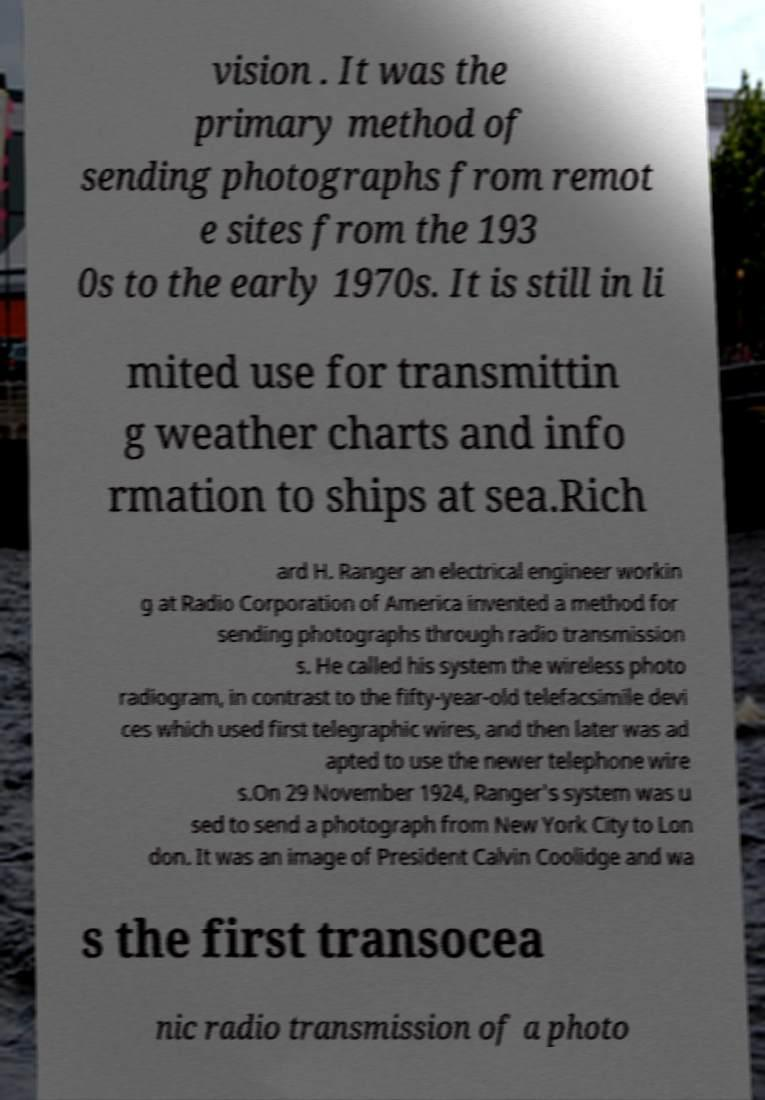For documentation purposes, I need the text within this image transcribed. Could you provide that? vision . It was the primary method of sending photographs from remot e sites from the 193 0s to the early 1970s. It is still in li mited use for transmittin g weather charts and info rmation to ships at sea.Rich ard H. Ranger an electrical engineer workin g at Radio Corporation of America invented a method for sending photographs through radio transmission s. He called his system the wireless photo radiogram, in contrast to the fifty-year-old telefacsimile devi ces which used first telegraphic wires, and then later was ad apted to use the newer telephone wire s.On 29 November 1924, Ranger's system was u sed to send a photograph from New York City to Lon don. It was an image of President Calvin Coolidge and wa s the first transocea nic radio transmission of a photo 